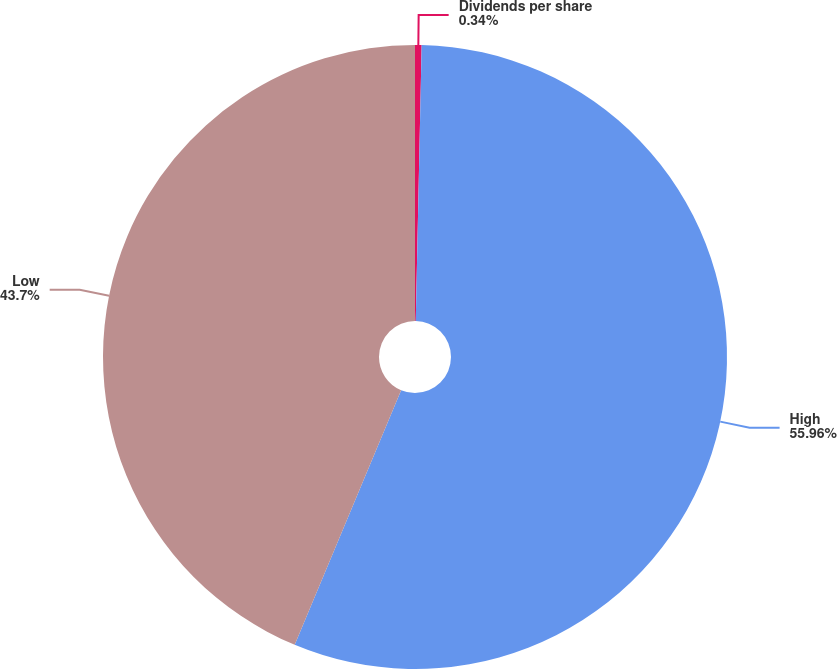Convert chart to OTSL. <chart><loc_0><loc_0><loc_500><loc_500><pie_chart><fcel>Dividends per share<fcel>High<fcel>Low<nl><fcel>0.34%<fcel>55.96%<fcel>43.7%<nl></chart> 